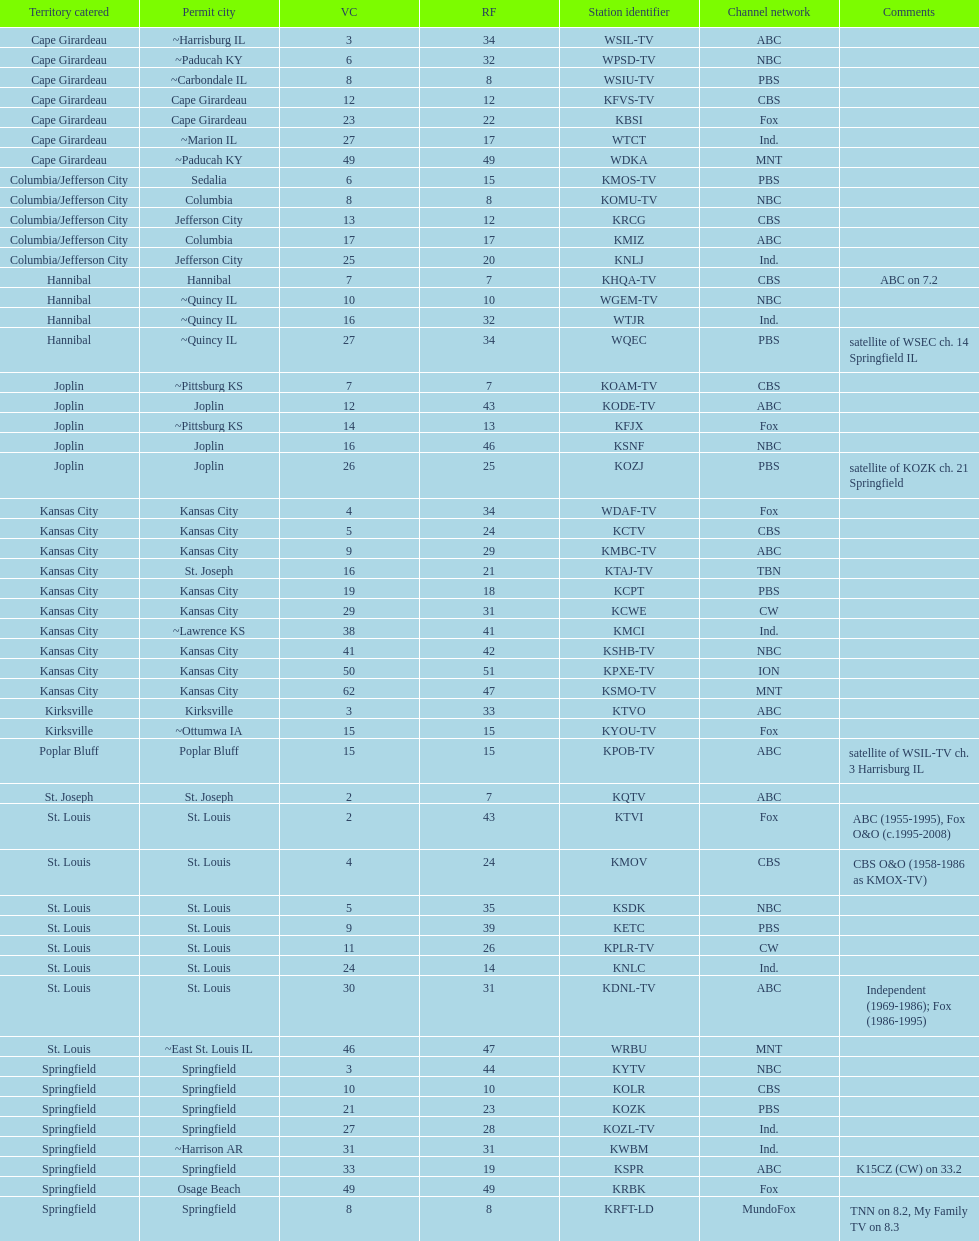What is the total number of stations under the cbs network? 7. 